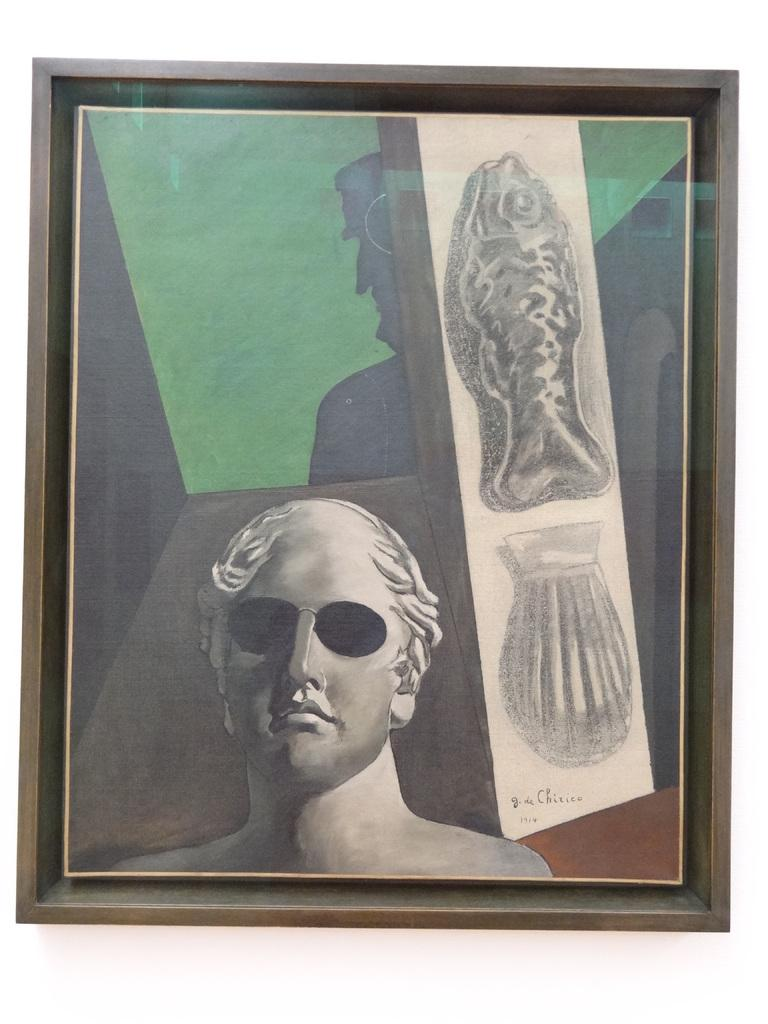What object can be seen in the image? There is a photo frame in the image. What might be contained within the photo frame? The photo frame may contain a photograph or other image. Can you describe the shape or style of the photo frame? The provided facts do not include information about the shape or style of the photo frame. What type of coal is being used to create a rhythm in the image? There is no coal or rhythm present in the image; it only features a photo frame. 